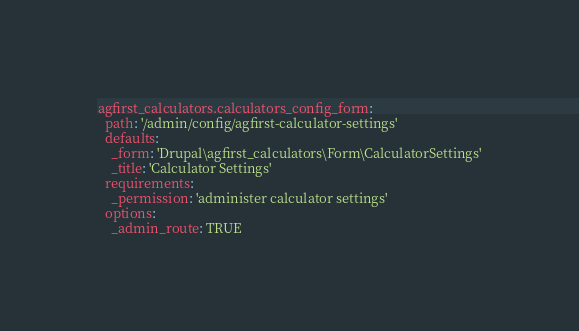Convert code to text. <code><loc_0><loc_0><loc_500><loc_500><_YAML_>agfirst_calculators.calculators_config_form:
  path: '/admin/config/agfirst-calculator-settings'
  defaults:
    _form: 'Drupal\agfirst_calculators\Form\CalculatorSettings'
    _title: 'Calculator Settings'
  requirements:
    _permission: 'administer calculator settings'
  options:
    _admin_route: TRUE
</code> 